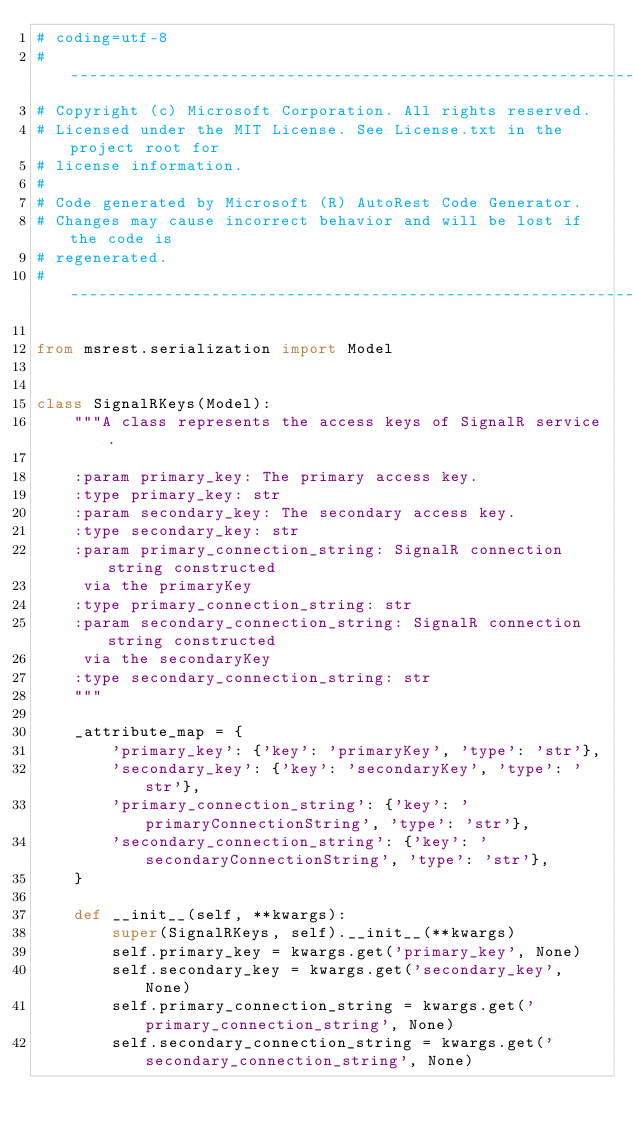<code> <loc_0><loc_0><loc_500><loc_500><_Python_># coding=utf-8
# --------------------------------------------------------------------------
# Copyright (c) Microsoft Corporation. All rights reserved.
# Licensed under the MIT License. See License.txt in the project root for
# license information.
#
# Code generated by Microsoft (R) AutoRest Code Generator.
# Changes may cause incorrect behavior and will be lost if the code is
# regenerated.
# --------------------------------------------------------------------------

from msrest.serialization import Model


class SignalRKeys(Model):
    """A class represents the access keys of SignalR service.

    :param primary_key: The primary access key.
    :type primary_key: str
    :param secondary_key: The secondary access key.
    :type secondary_key: str
    :param primary_connection_string: SignalR connection string constructed
     via the primaryKey
    :type primary_connection_string: str
    :param secondary_connection_string: SignalR connection string constructed
     via the secondaryKey
    :type secondary_connection_string: str
    """

    _attribute_map = {
        'primary_key': {'key': 'primaryKey', 'type': 'str'},
        'secondary_key': {'key': 'secondaryKey', 'type': 'str'},
        'primary_connection_string': {'key': 'primaryConnectionString', 'type': 'str'},
        'secondary_connection_string': {'key': 'secondaryConnectionString', 'type': 'str'},
    }

    def __init__(self, **kwargs):
        super(SignalRKeys, self).__init__(**kwargs)
        self.primary_key = kwargs.get('primary_key', None)
        self.secondary_key = kwargs.get('secondary_key', None)
        self.primary_connection_string = kwargs.get('primary_connection_string', None)
        self.secondary_connection_string = kwargs.get('secondary_connection_string', None)
</code> 